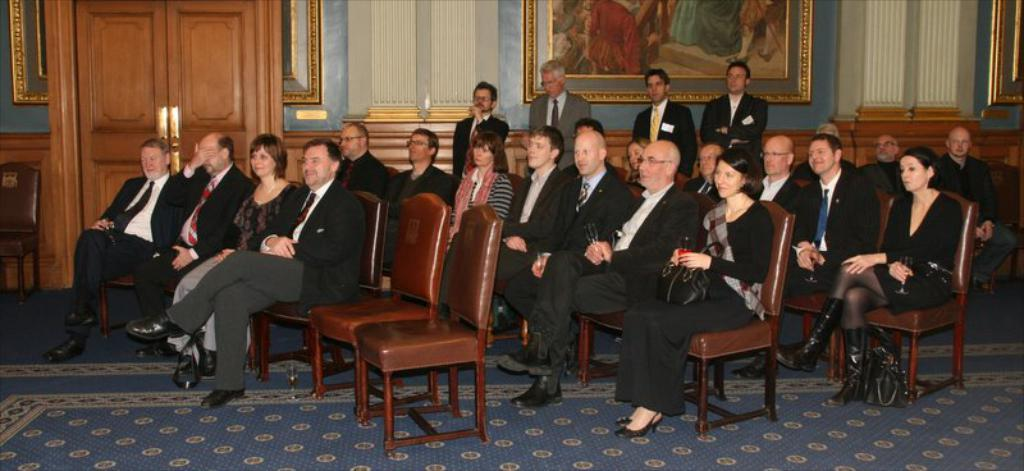What are the people in the image doing? There is a group of people sitting in chairs, and they are looking at something. Are there any other people in the image besides those sitting in chairs? Yes, there are a few people standing behind the seated group. What type of appliance is being used by the people in the image? There is no appliance visible in the image. What substance is being discussed by the people in the image? The image does not provide information about any specific substance being discussed by the people. 